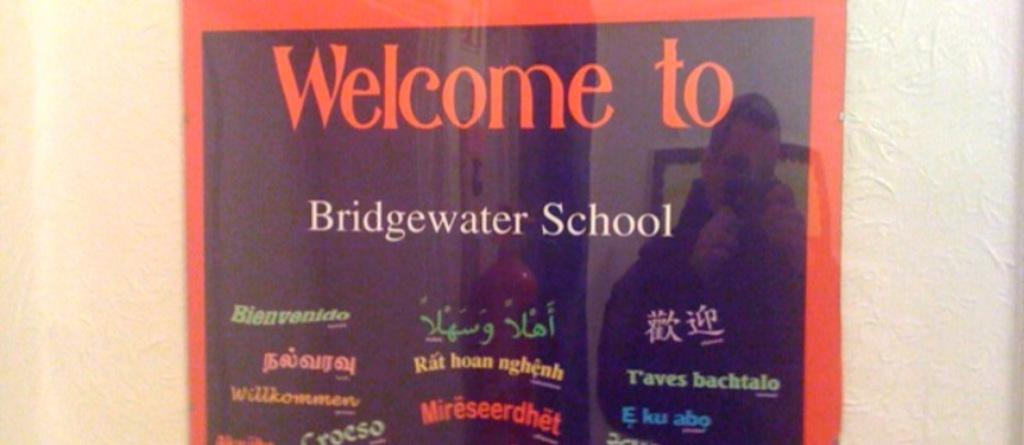<image>
Write a terse but informative summary of the picture. A framed sign welcomes visitors to Bridgewater School. 